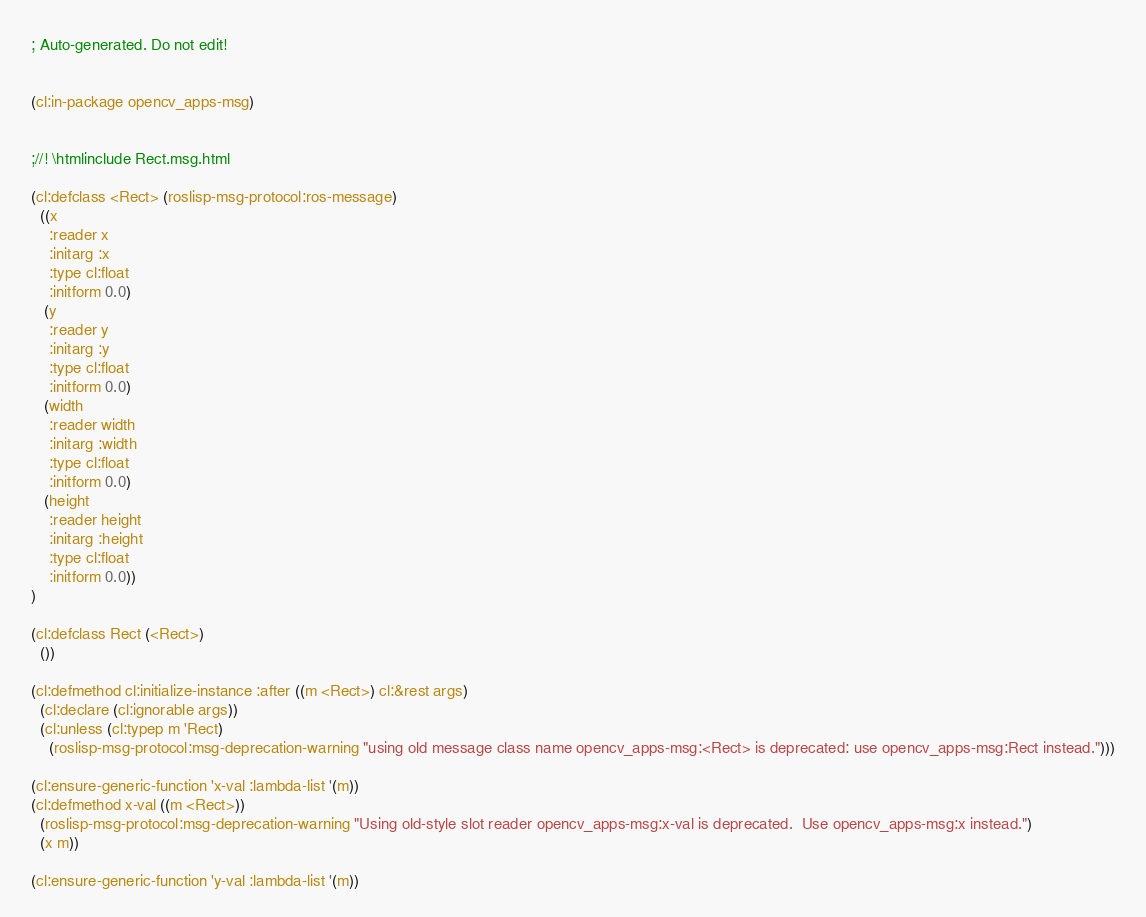Convert code to text. <code><loc_0><loc_0><loc_500><loc_500><_Lisp_>; Auto-generated. Do not edit!


(cl:in-package opencv_apps-msg)


;//! \htmlinclude Rect.msg.html

(cl:defclass <Rect> (roslisp-msg-protocol:ros-message)
  ((x
    :reader x
    :initarg :x
    :type cl:float
    :initform 0.0)
   (y
    :reader y
    :initarg :y
    :type cl:float
    :initform 0.0)
   (width
    :reader width
    :initarg :width
    :type cl:float
    :initform 0.0)
   (height
    :reader height
    :initarg :height
    :type cl:float
    :initform 0.0))
)

(cl:defclass Rect (<Rect>)
  ())

(cl:defmethod cl:initialize-instance :after ((m <Rect>) cl:&rest args)
  (cl:declare (cl:ignorable args))
  (cl:unless (cl:typep m 'Rect)
    (roslisp-msg-protocol:msg-deprecation-warning "using old message class name opencv_apps-msg:<Rect> is deprecated: use opencv_apps-msg:Rect instead.")))

(cl:ensure-generic-function 'x-val :lambda-list '(m))
(cl:defmethod x-val ((m <Rect>))
  (roslisp-msg-protocol:msg-deprecation-warning "Using old-style slot reader opencv_apps-msg:x-val is deprecated.  Use opencv_apps-msg:x instead.")
  (x m))

(cl:ensure-generic-function 'y-val :lambda-list '(m))</code> 